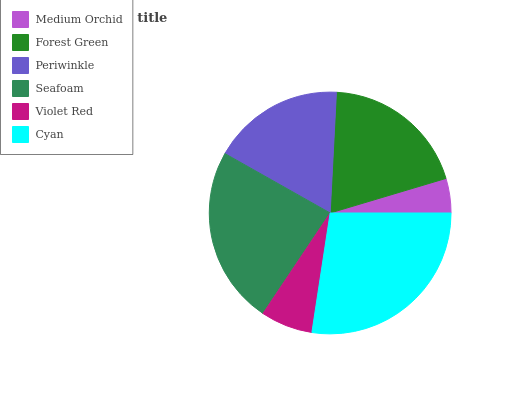Is Medium Orchid the minimum?
Answer yes or no. Yes. Is Cyan the maximum?
Answer yes or no. Yes. Is Forest Green the minimum?
Answer yes or no. No. Is Forest Green the maximum?
Answer yes or no. No. Is Forest Green greater than Medium Orchid?
Answer yes or no. Yes. Is Medium Orchid less than Forest Green?
Answer yes or no. Yes. Is Medium Orchid greater than Forest Green?
Answer yes or no. No. Is Forest Green less than Medium Orchid?
Answer yes or no. No. Is Forest Green the high median?
Answer yes or no. Yes. Is Periwinkle the low median?
Answer yes or no. Yes. Is Cyan the high median?
Answer yes or no. No. Is Cyan the low median?
Answer yes or no. No. 